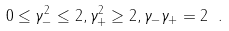<formula> <loc_0><loc_0><loc_500><loc_500>0 \leq \gamma _ { - } ^ { 2 } \leq 2 , \gamma _ { + } ^ { 2 } \geq 2 , \gamma _ { - } \gamma _ { + } = 2 \ .</formula> 